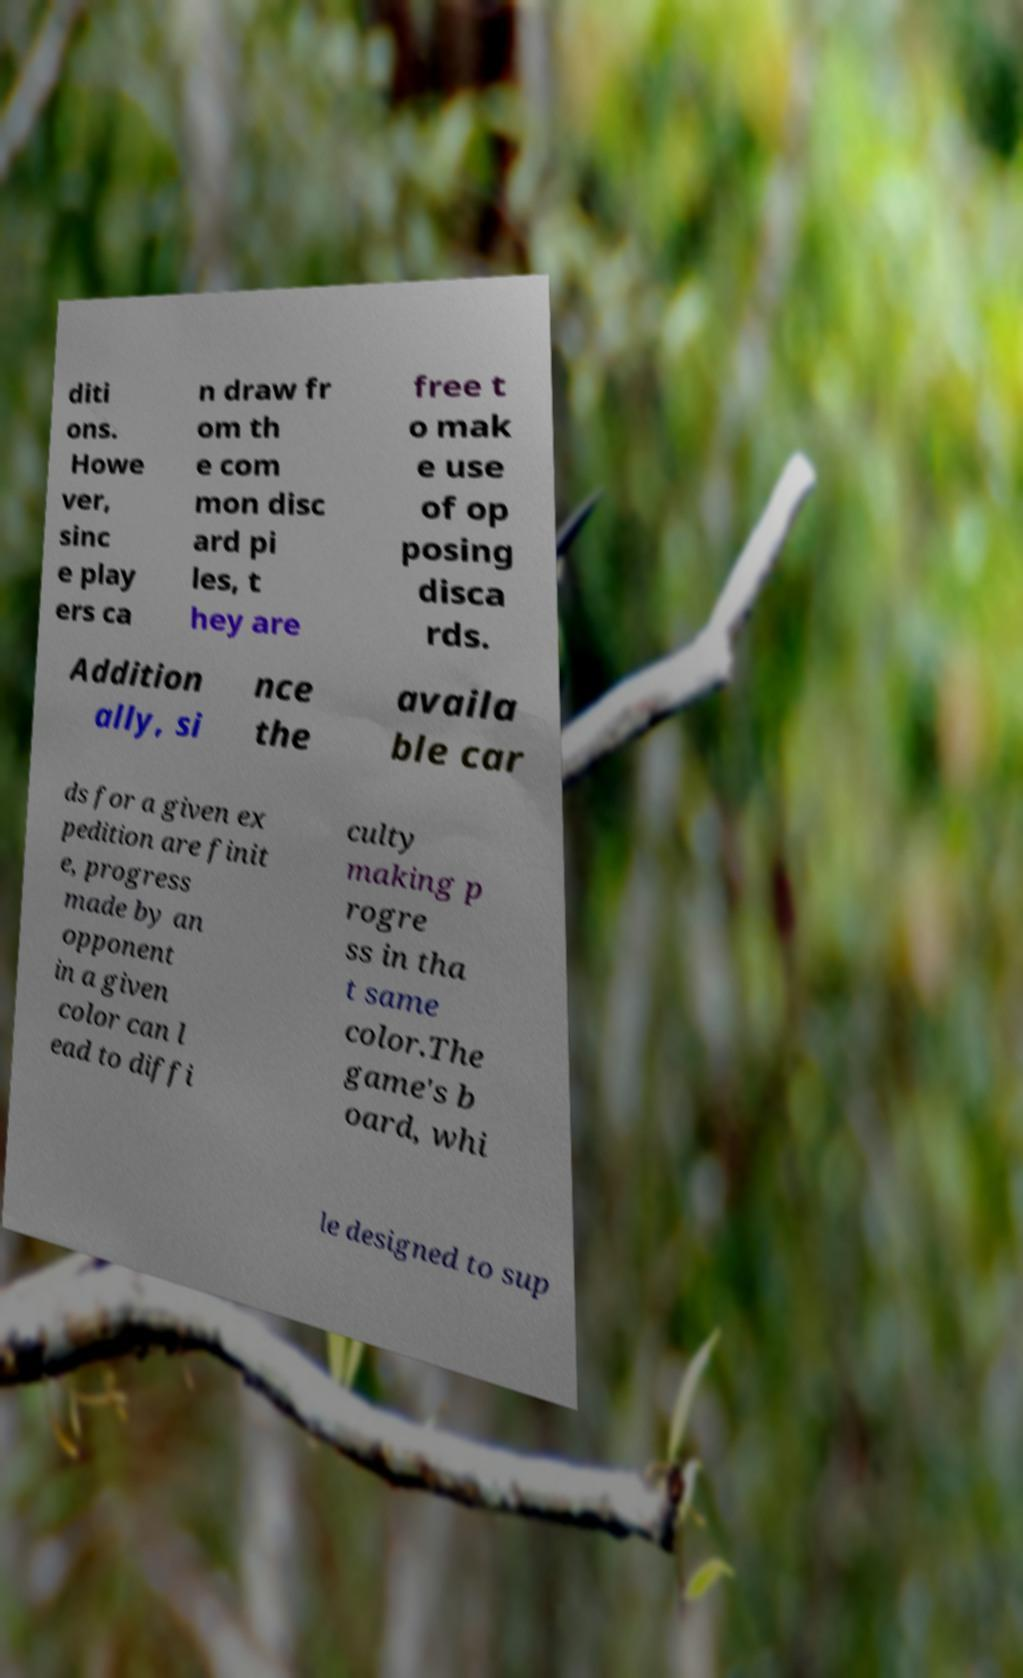For documentation purposes, I need the text within this image transcribed. Could you provide that? diti ons. Howe ver, sinc e play ers ca n draw fr om th e com mon disc ard pi les, t hey are free t o mak e use of op posing disca rds. Addition ally, si nce the availa ble car ds for a given ex pedition are finit e, progress made by an opponent in a given color can l ead to diffi culty making p rogre ss in tha t same color.The game's b oard, whi le designed to sup 